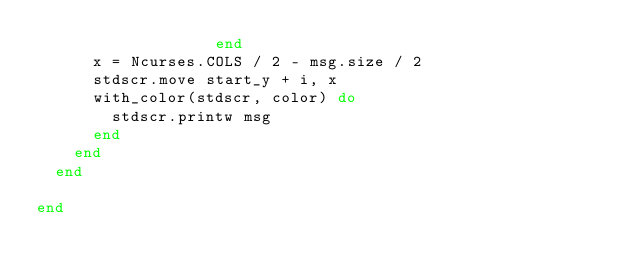<code> <loc_0><loc_0><loc_500><loc_500><_Ruby_>                   end
      x = Ncurses.COLS / 2 - msg.size / 2
      stdscr.move start_y + i, x
      with_color(stdscr, color) do
        stdscr.printw msg
      end
    end
  end

end

</code> 